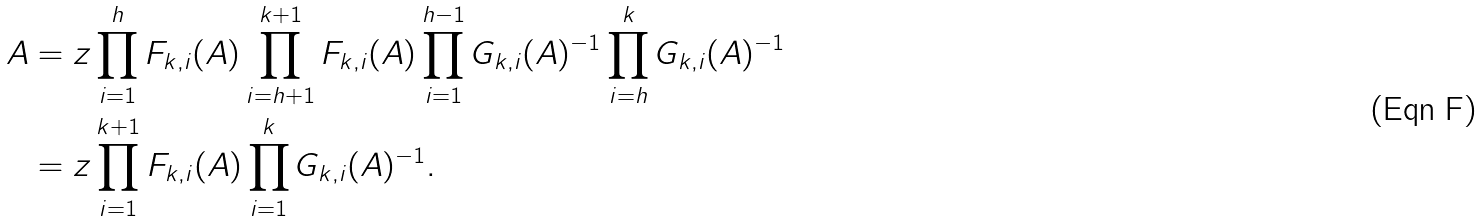Convert formula to latex. <formula><loc_0><loc_0><loc_500><loc_500>A & = z \prod _ { i = 1 } ^ { h } F _ { k , i } ( A ) \prod _ { i = h + 1 } ^ { k + 1 } F _ { k , i } ( A ) \prod _ { i = 1 } ^ { h - 1 } G _ { k , i } ( A ) ^ { - 1 } \prod _ { i = h } ^ { k } G _ { k , i } ( A ) ^ { - 1 } \\ & = z \prod _ { i = 1 } ^ { k + 1 } F _ { k , i } ( A ) \prod _ { i = 1 } ^ { k } G _ { k , i } ( A ) ^ { - 1 } .</formula> 